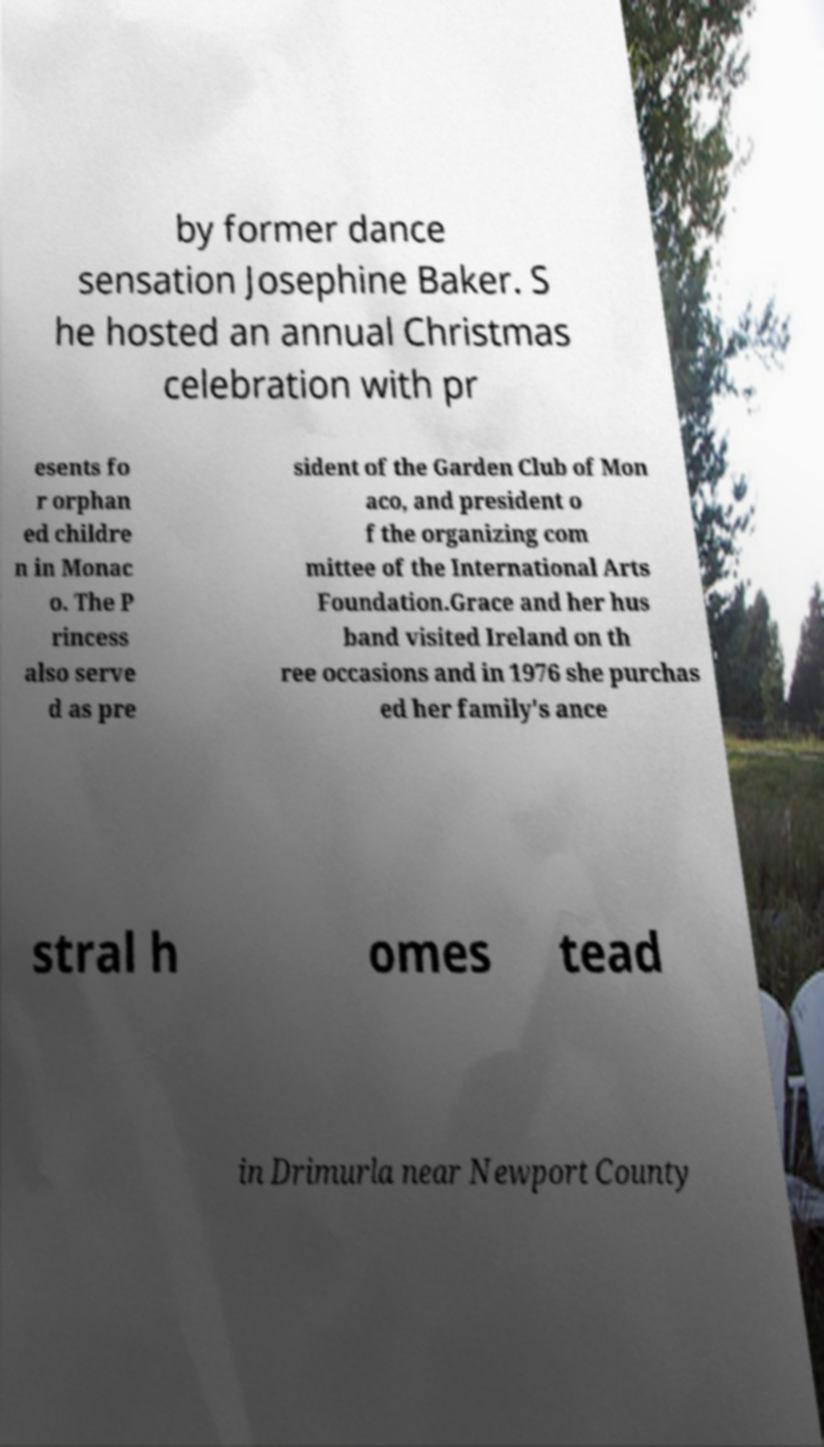Can you accurately transcribe the text from the provided image for me? by former dance sensation Josephine Baker. S he hosted an annual Christmas celebration with pr esents fo r orphan ed childre n in Monac o. The P rincess also serve d as pre sident of the Garden Club of Mon aco, and president o f the organizing com mittee of the International Arts Foundation.Grace and her hus band visited Ireland on th ree occasions and in 1976 she purchas ed her family's ance stral h omes tead in Drimurla near Newport County 